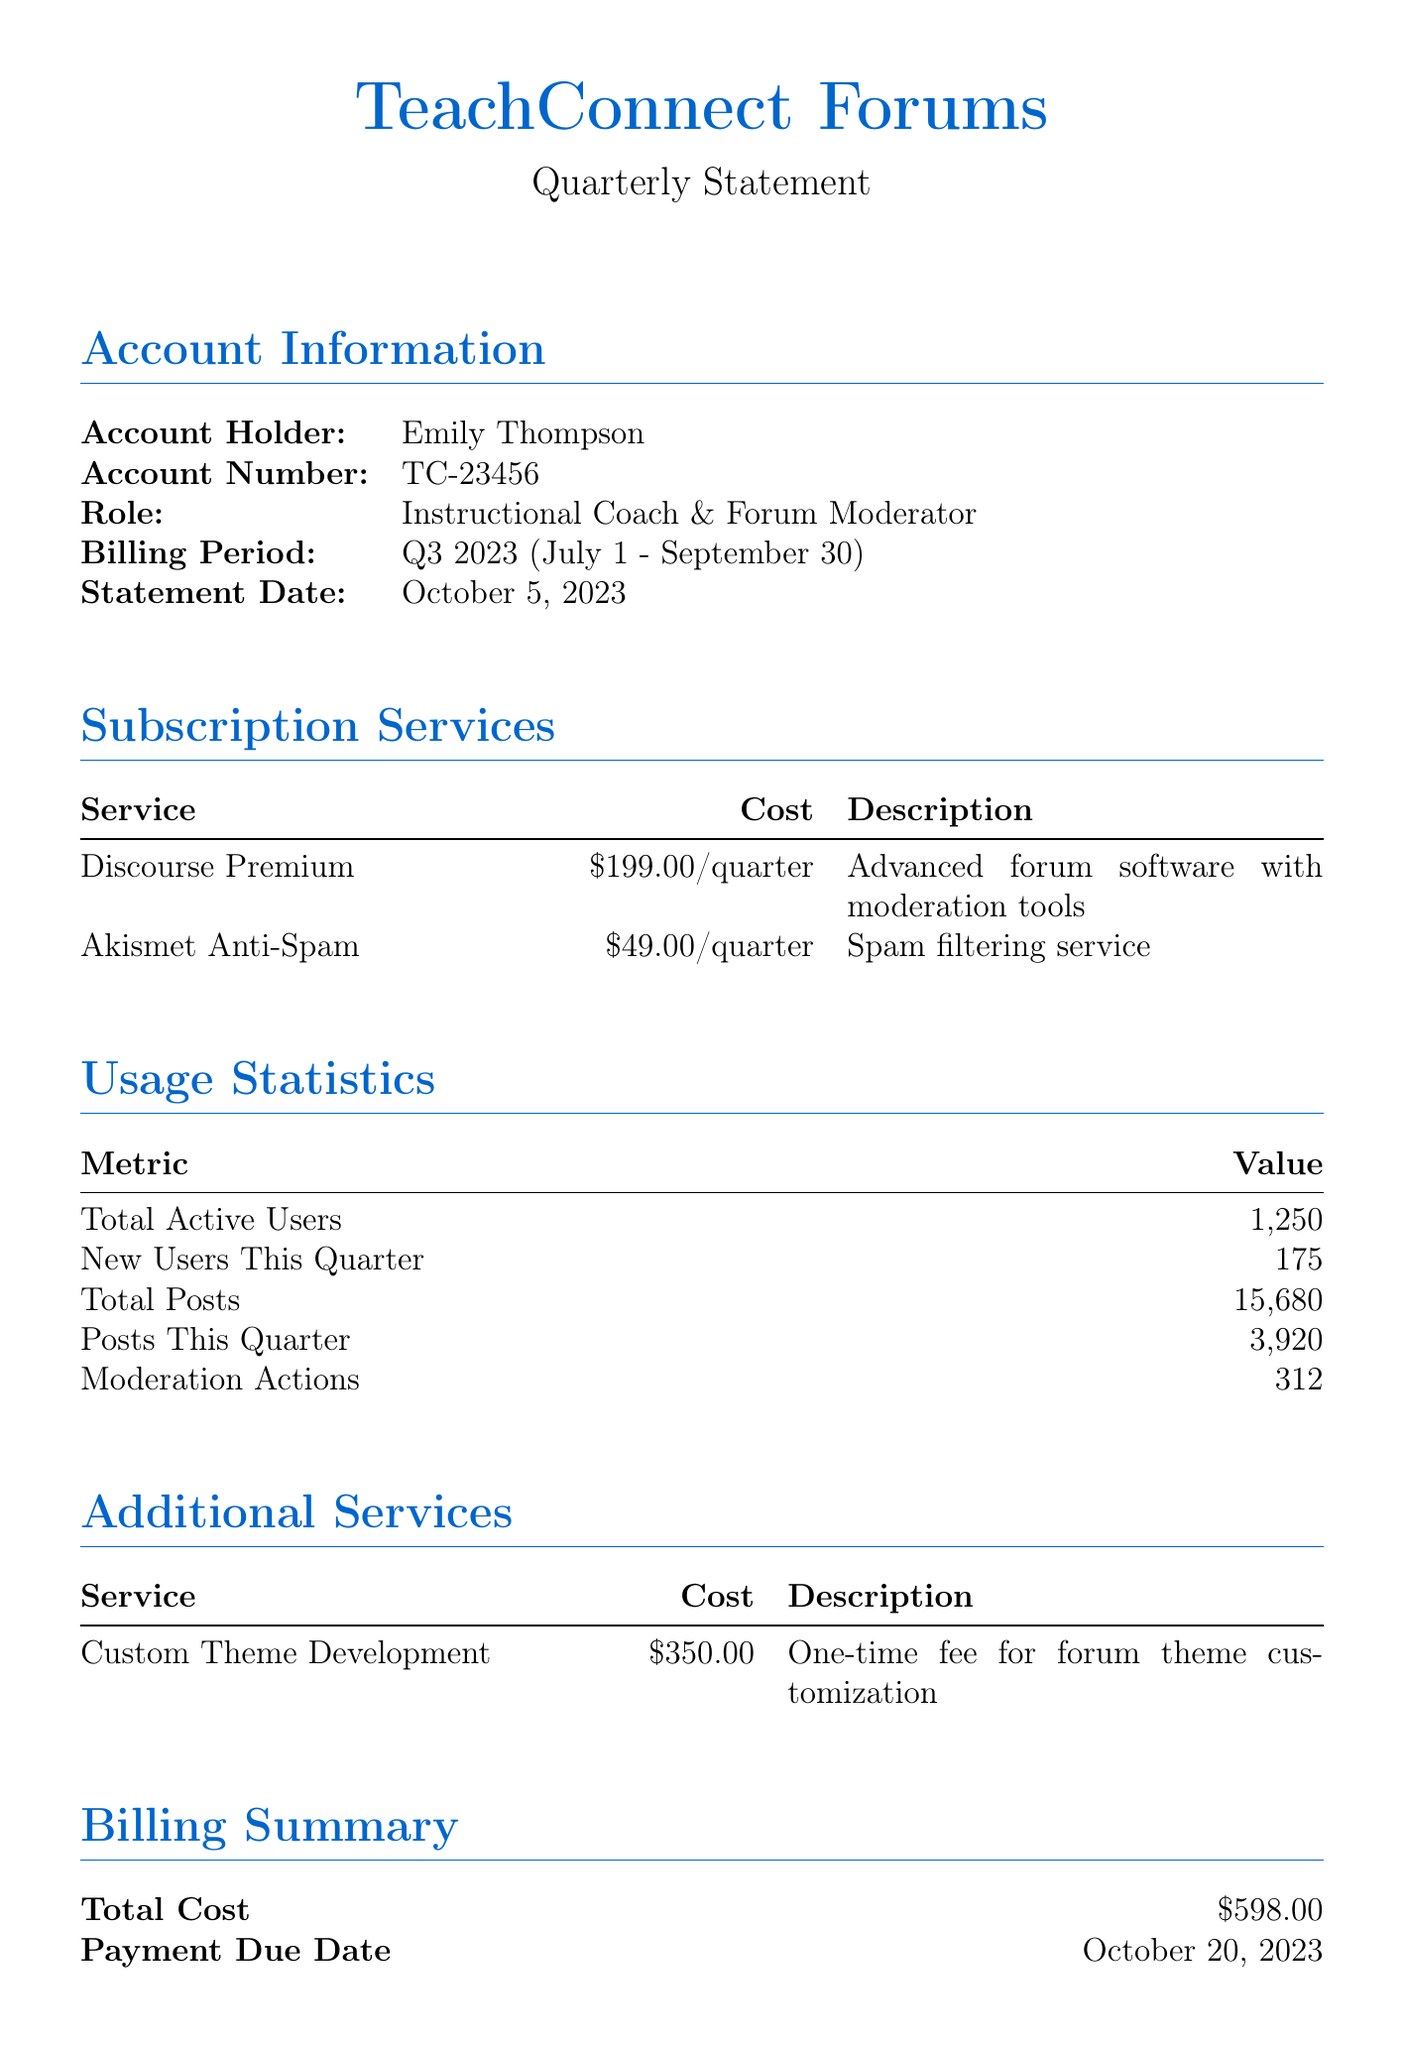What is the account holder's name? The account holder's name is listed in the account information section.
Answer: Emily Thompson What is the billing period for this statement? The billing period is specified in the account information section.
Answer: Q3 2023 (July 1 - September 30) How many new users joined this quarter? The number of new users is found in the usage statistics section.
Answer: 175 What is the total number of posts made this quarter? The total posts made this quarter is indicated in the usage statistics section.
Answer: 3,920 What is the cost of the Discourse Premium service? The cost of the service can be found in the subscription services table.
Answer: $199.00/quarter What is the total cost of all services listed? The total cost is calculated from the subscription and additional services sections.
Answer: $598.00 What is the payment due date? The payment due date is mentioned in the billing summary section.
Answer: October 20, 2023 What payment methods are accepted? Payment methods are listed in the payment methods section.
Answer: Credit Card, PayPal, Bank Transfer How many moderation actions were taken this quarter? The number of moderation actions appears in the usage statistics section.
Answer: 312 